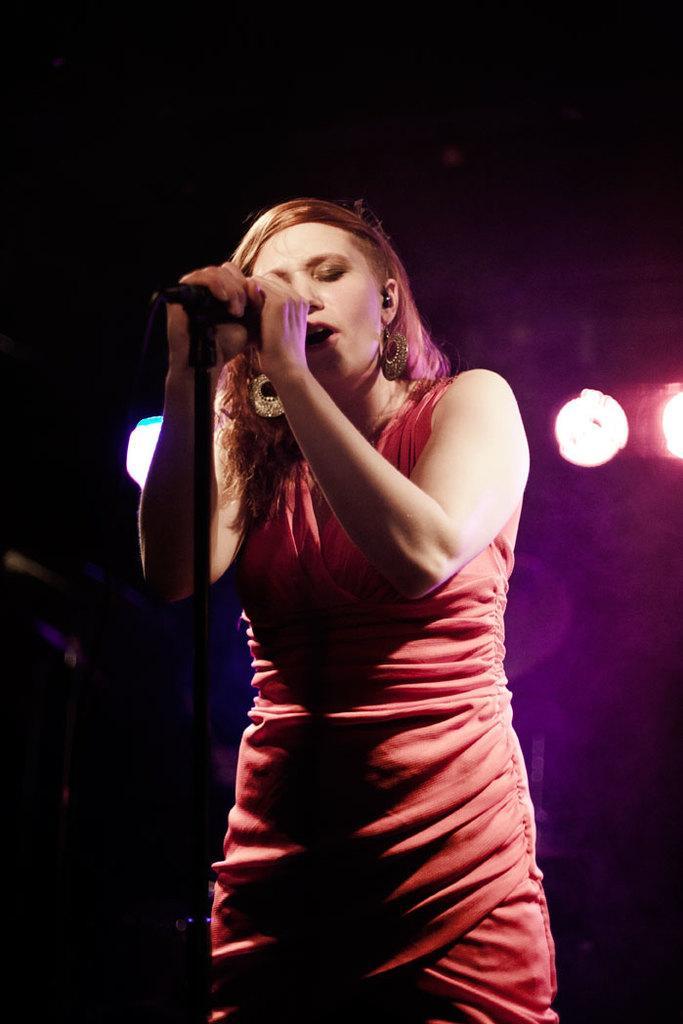In one or two sentences, can you explain what this image depicts? There is a woman standing and holding microphone and singing. In the background it is dark and we can see lights. 